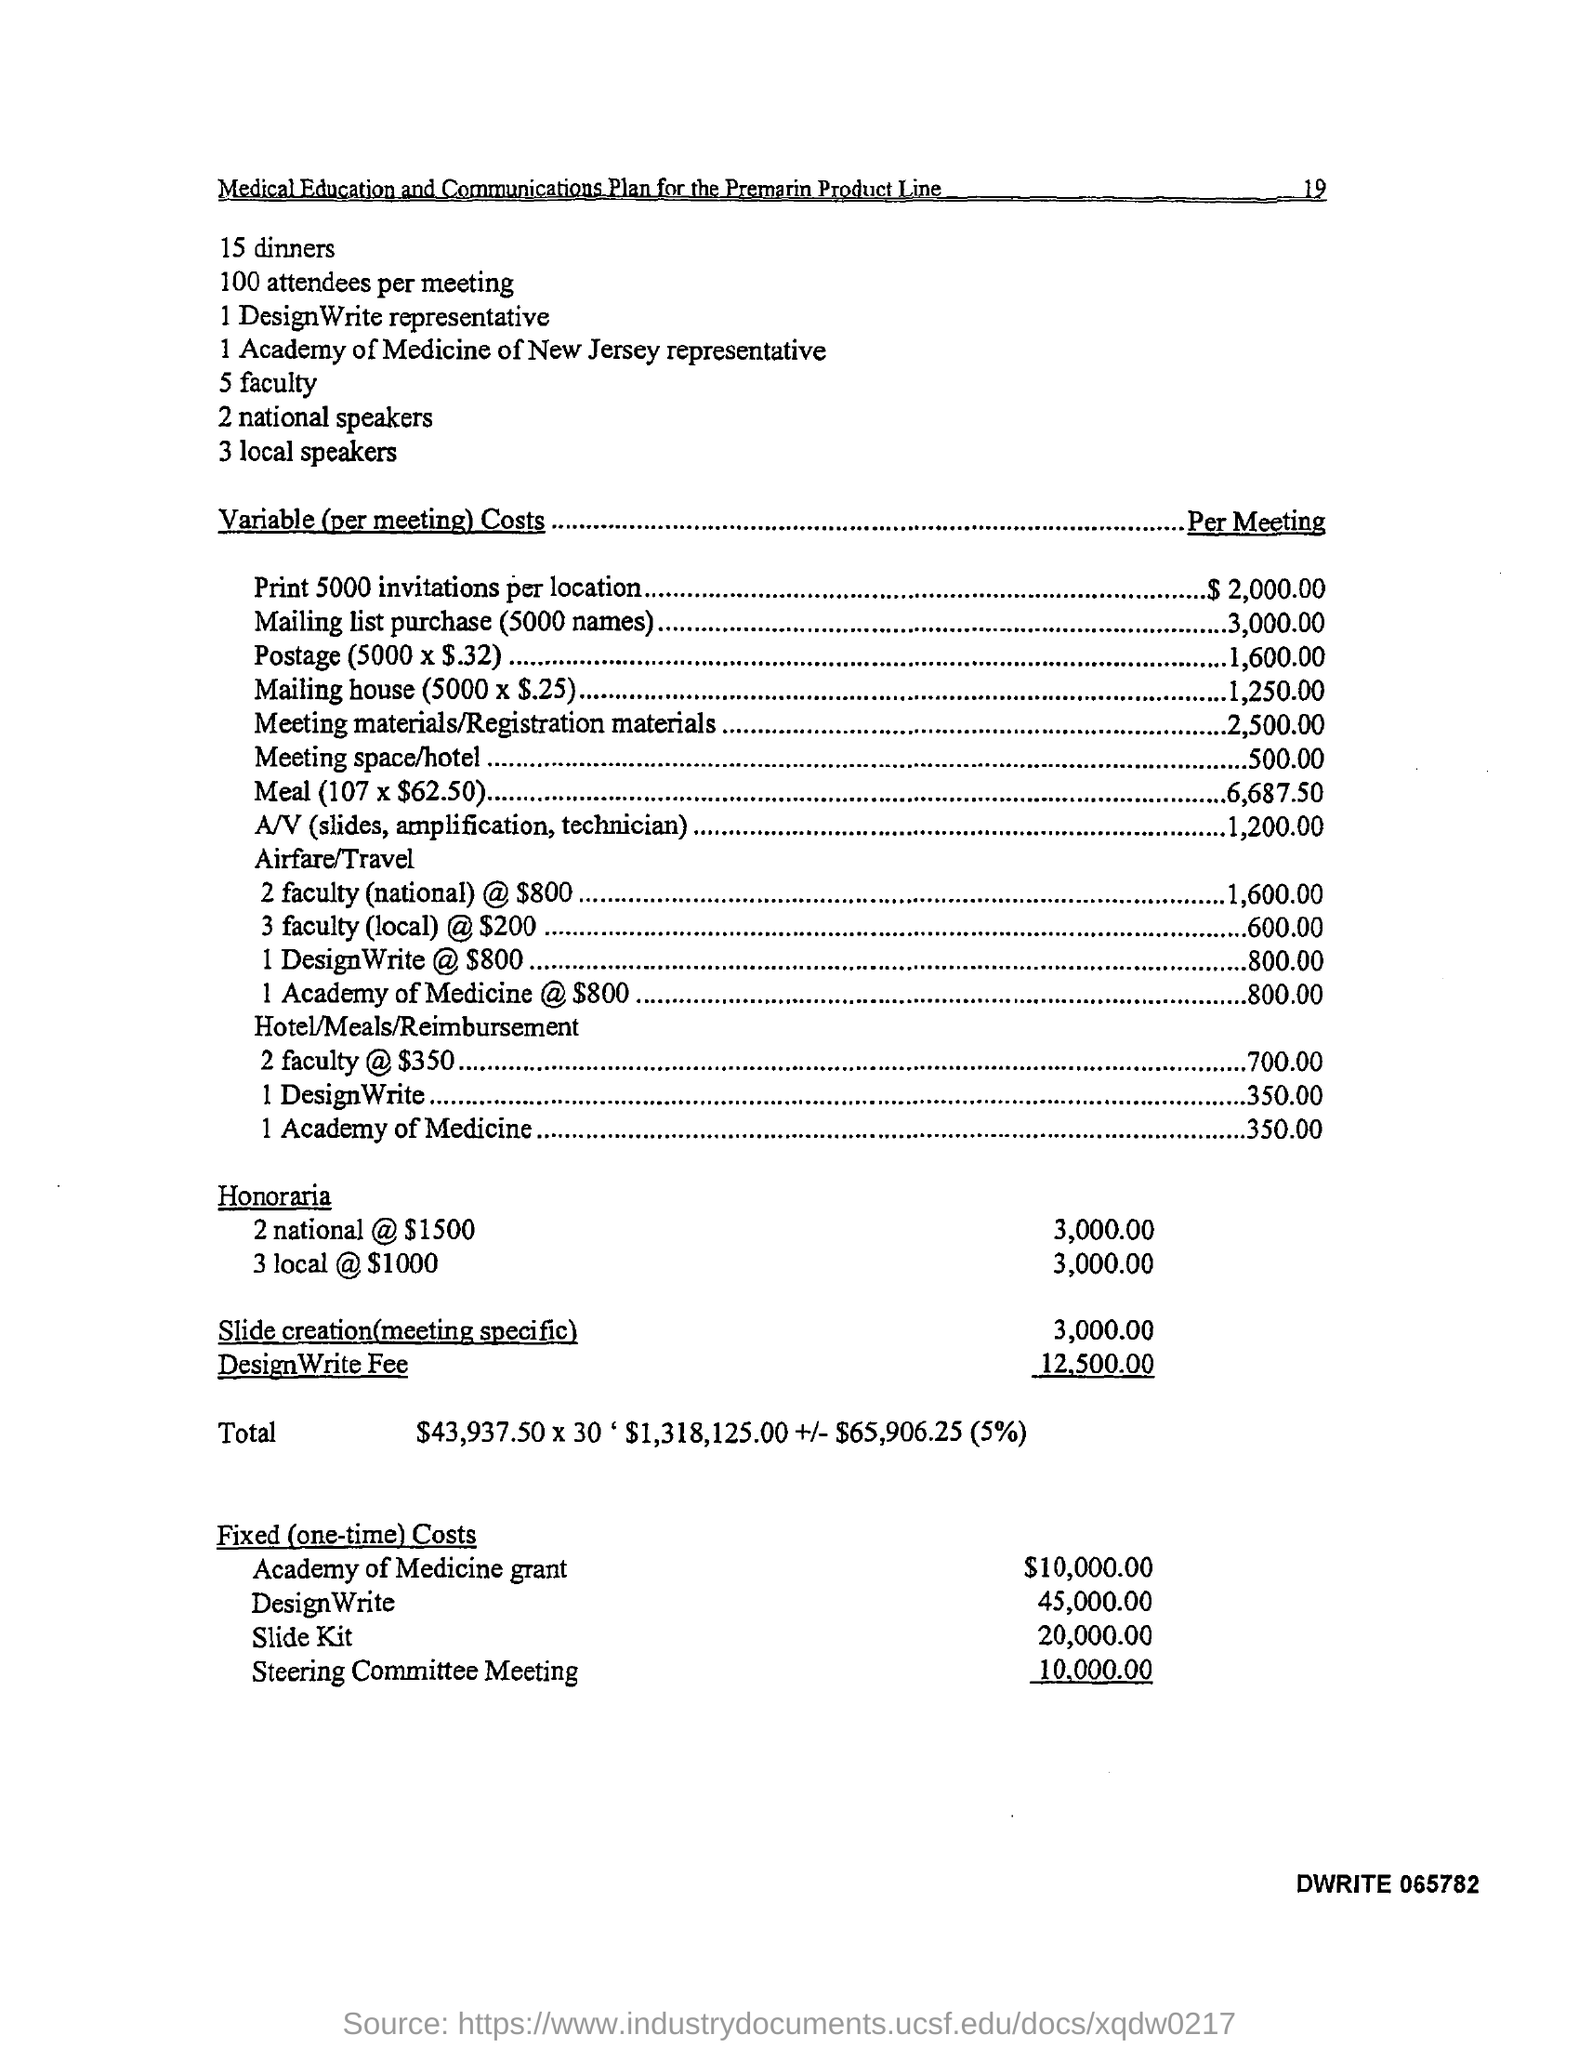What is the number of dinners?
Your response must be concise. 15. How many attendees per meeting
Offer a very short reply. 100. How many faculties are there?
Give a very brief answer. 5. 